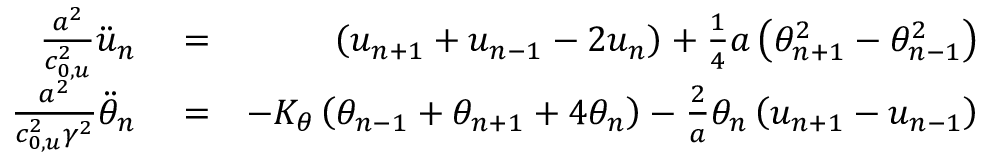Convert formula to latex. <formula><loc_0><loc_0><loc_500><loc_500>\begin{array} { r l r } { \frac { { { a } ^ { 2 } } } { c _ { 0 , u } ^ { 2 } } { { \ddot { u } } _ { n } } } & = } & { \left ( { { u } _ { n + 1 } } + { { u } _ { n - 1 } } - 2 { { u } _ { n } } \right ) + \frac { 1 } { 4 } a \left ( \theta _ { n + 1 } ^ { 2 } - \theta _ { n - 1 } ^ { 2 } \right ) } \\ { \frac { { { a } ^ { 2 } } } { c _ { 0 , u } ^ { 2 } { { \gamma } ^ { 2 } } } { { { \ddot { \theta } } } _ { n } } } & = } & { - { { K } _ { \theta } } \left ( { { \theta } _ { n - 1 } } + { { \theta } _ { n + 1 } } + 4 { { \theta } _ { n } } \right ) - \frac { 2 } { a } { { \theta } _ { n } } \left ( { { u } _ { n + 1 } } - { { u } _ { n - 1 } } \right ) } \end{array}</formula> 